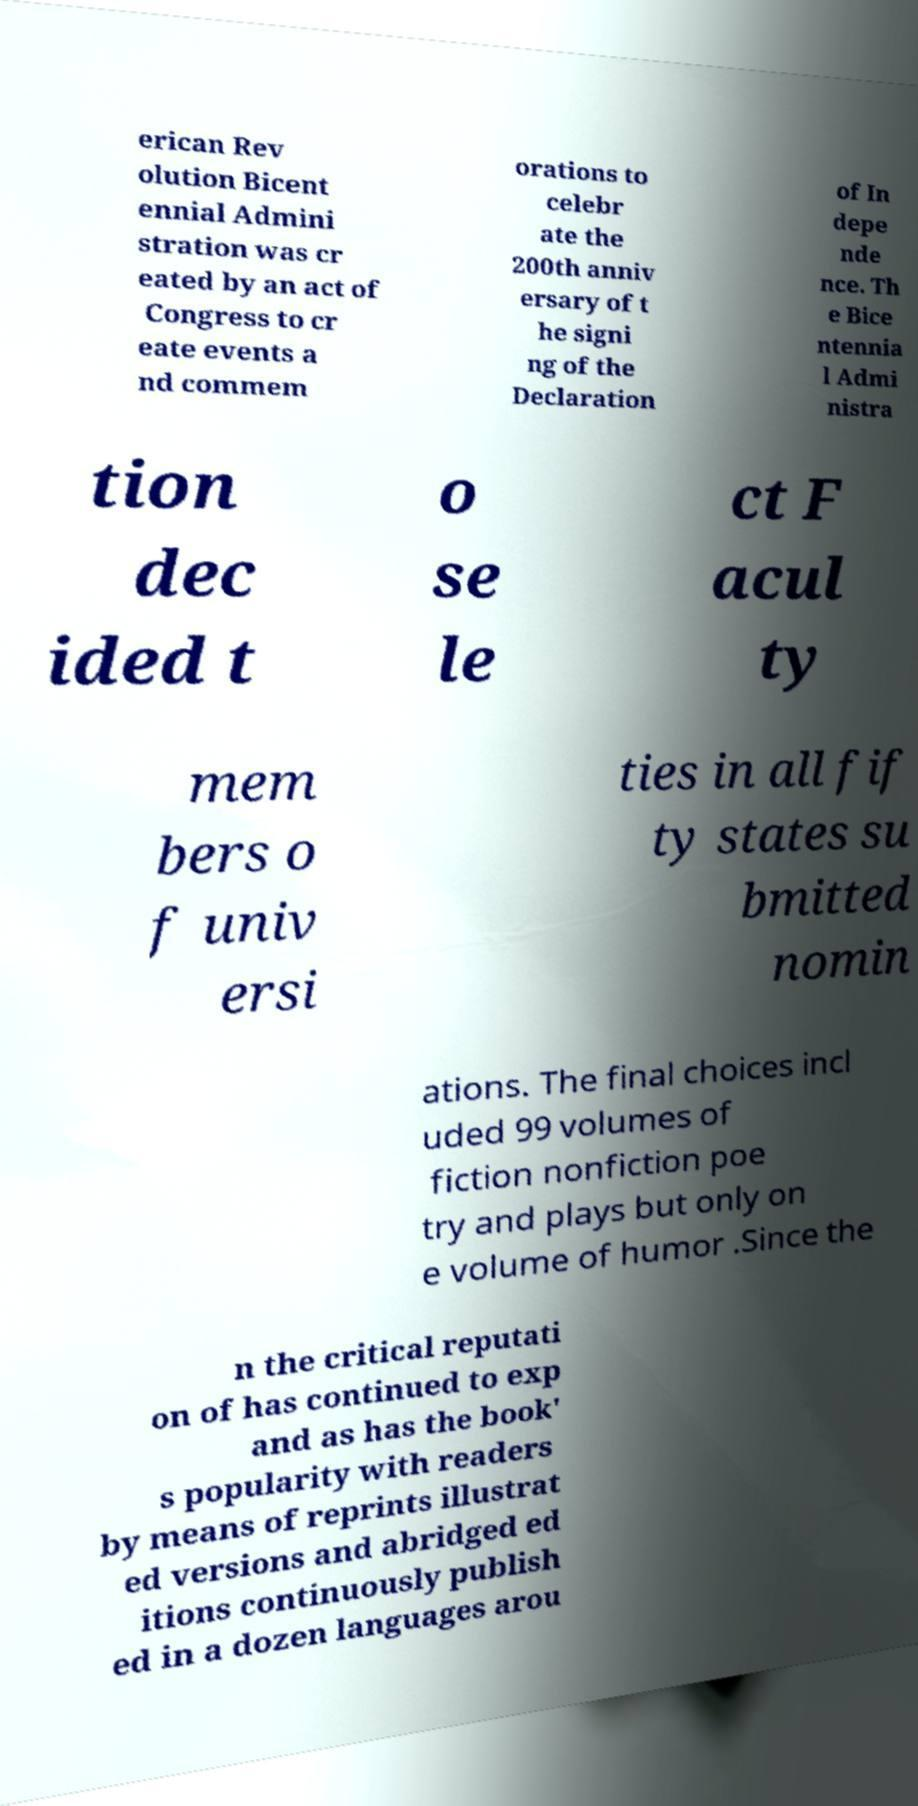There's text embedded in this image that I need extracted. Can you transcribe it verbatim? erican Rev olution Bicent ennial Admini stration was cr eated by an act of Congress to cr eate events a nd commem orations to celebr ate the 200th anniv ersary of t he signi ng of the Declaration of In depe nde nce. Th e Bice ntennia l Admi nistra tion dec ided t o se le ct F acul ty mem bers o f univ ersi ties in all fif ty states su bmitted nomin ations. The final choices incl uded 99 volumes of fiction nonfiction poe try and plays but only on e volume of humor .Since the n the critical reputati on of has continued to exp and as has the book' s popularity with readers by means of reprints illustrat ed versions and abridged ed itions continuously publish ed in a dozen languages arou 